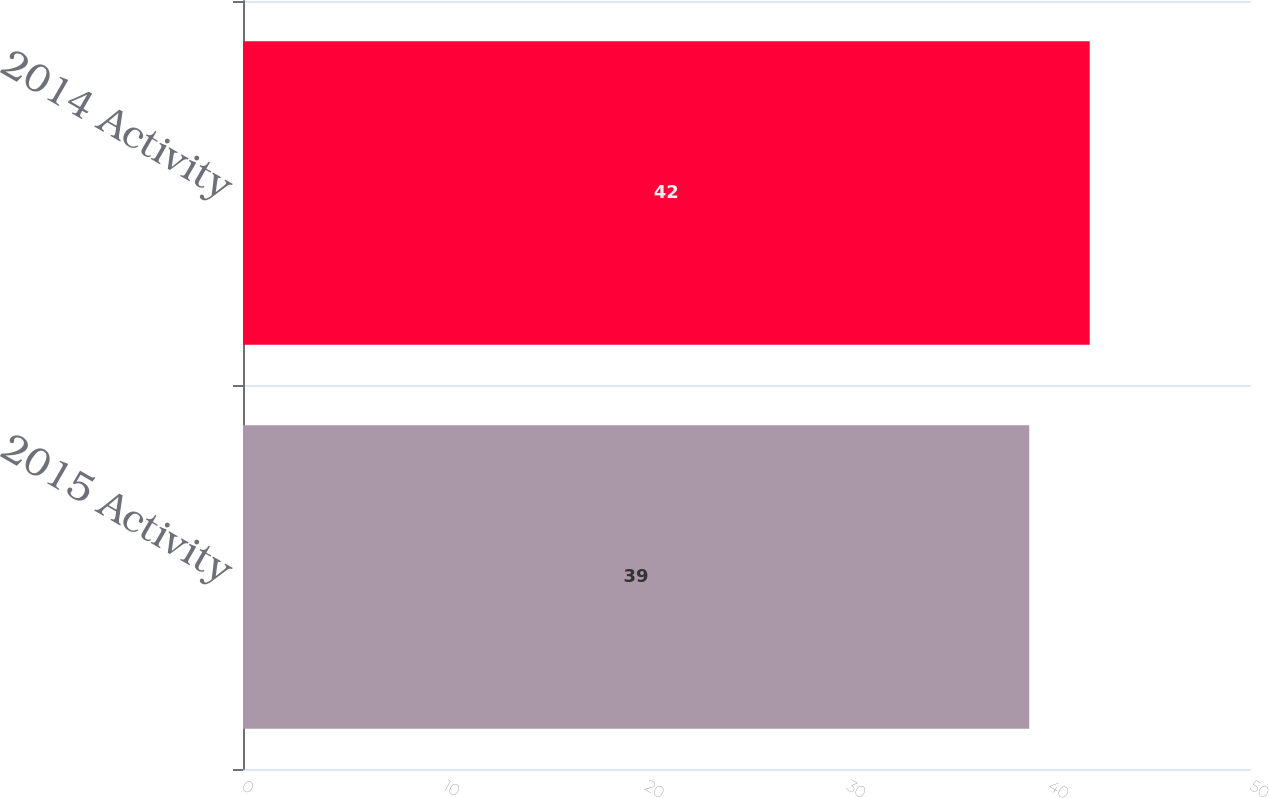Convert chart. <chart><loc_0><loc_0><loc_500><loc_500><bar_chart><fcel>2015 Activity<fcel>2014 Activity<nl><fcel>39<fcel>42<nl></chart> 